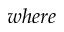Convert formula to latex. <formula><loc_0><loc_0><loc_500><loc_500>w h e r e</formula> 